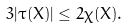Convert formula to latex. <formula><loc_0><loc_0><loc_500><loc_500>3 | \tau ( X ) | \leq 2 \chi ( X ) .</formula> 